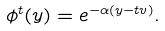<formula> <loc_0><loc_0><loc_500><loc_500>\phi ^ { t } ( y ) = e ^ { - \alpha ( y - t v ) } .</formula> 